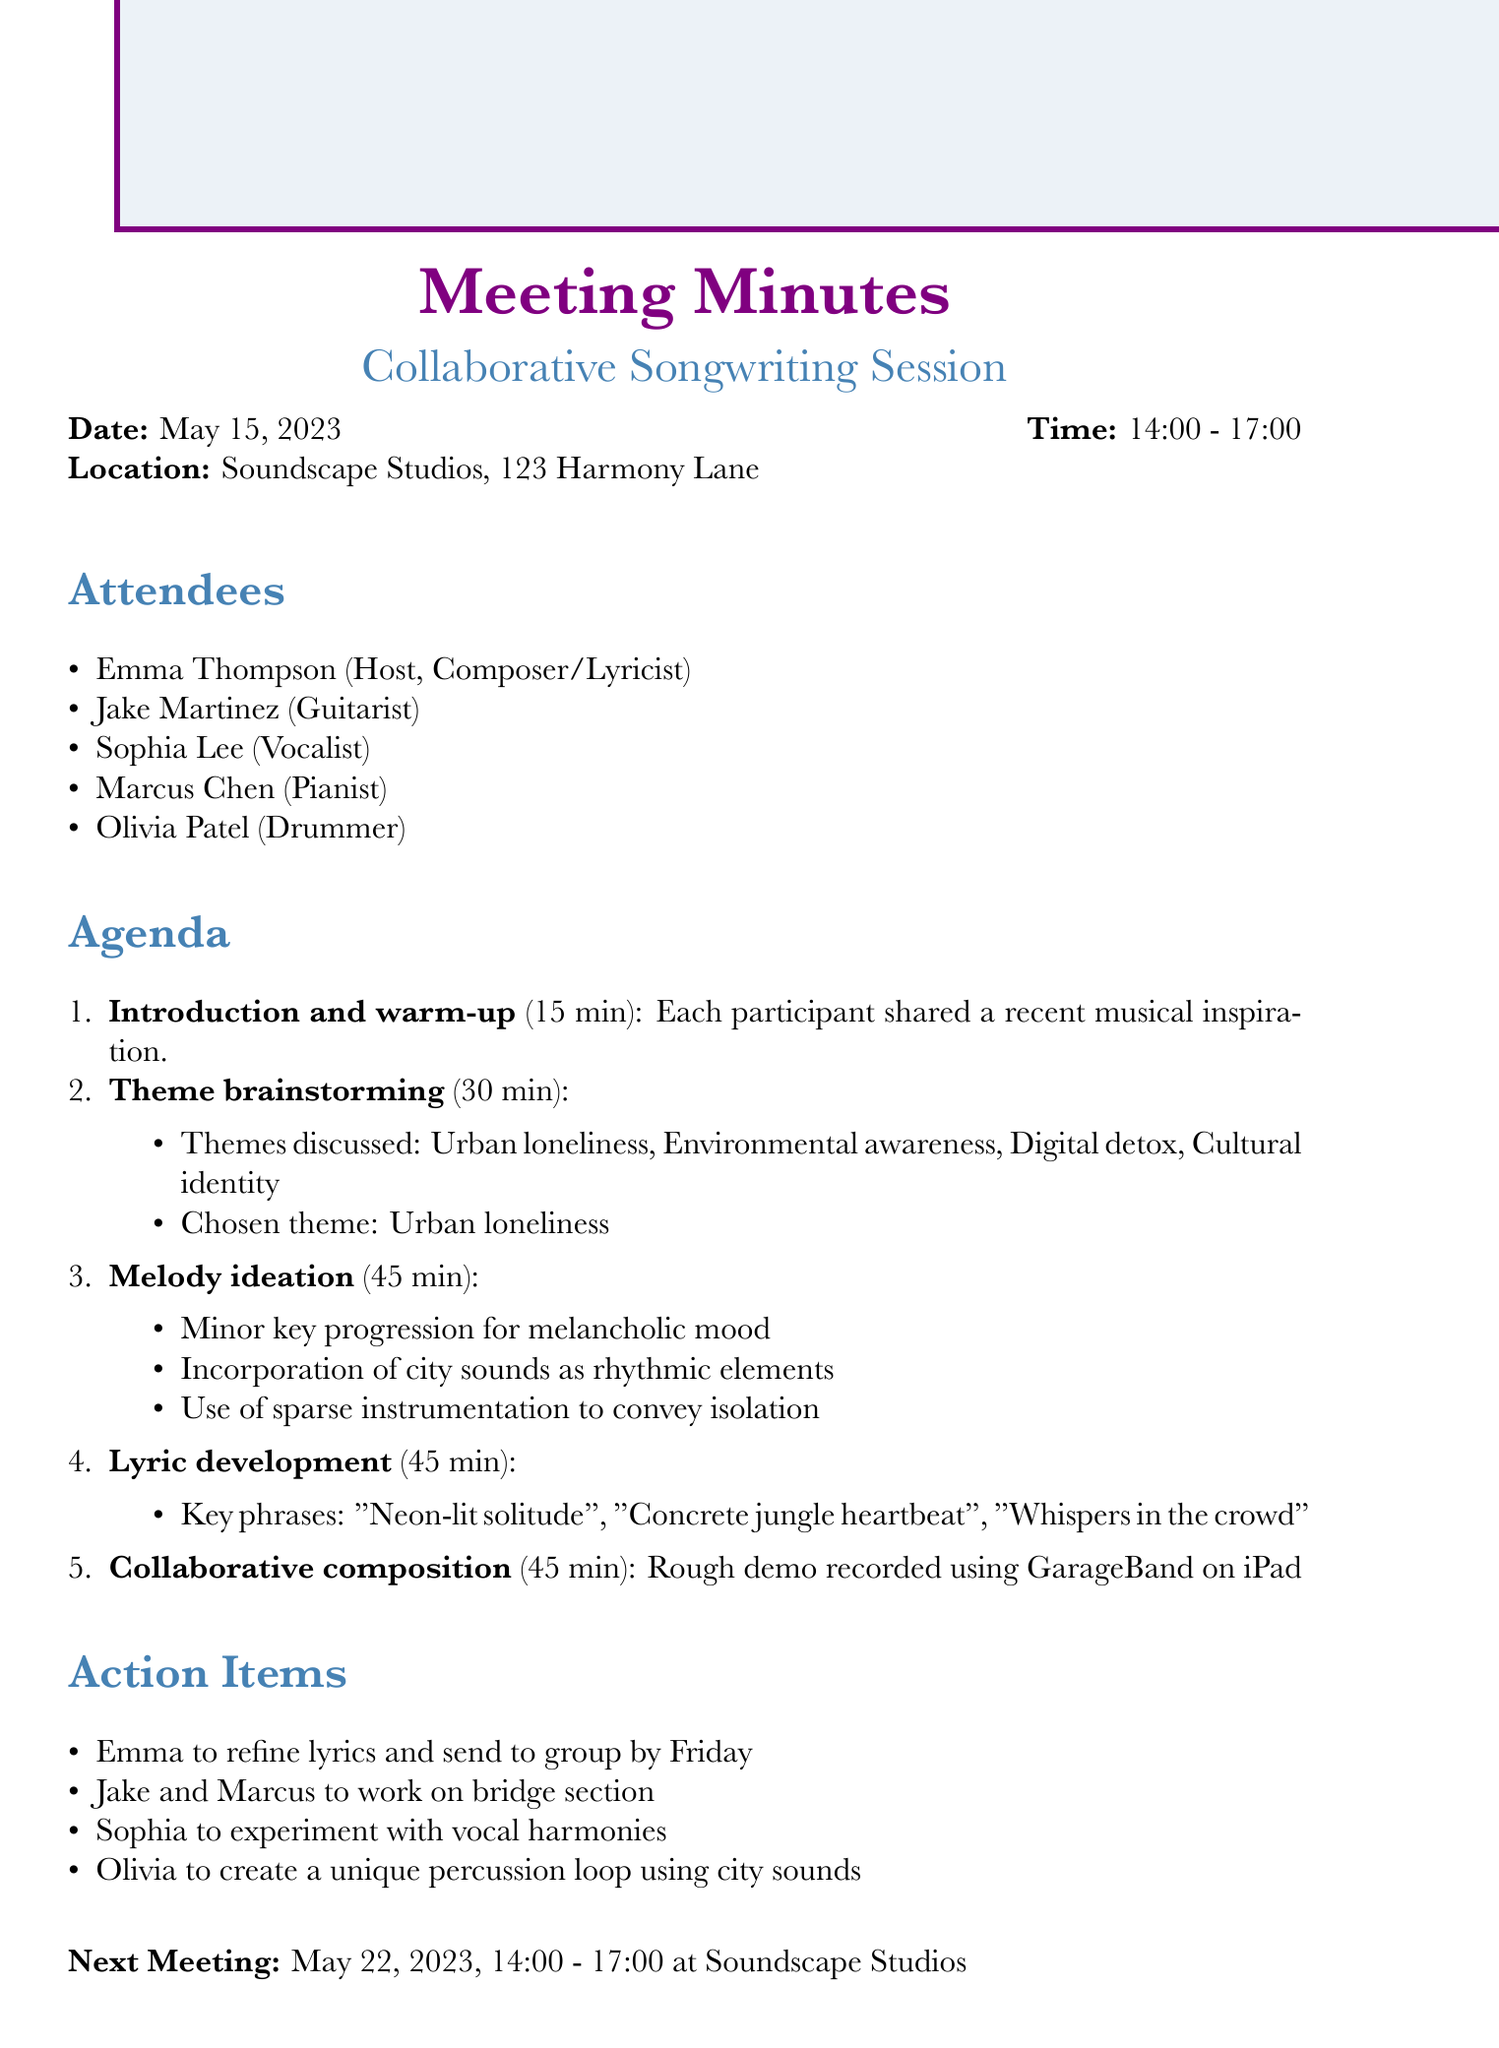what is the date of the meeting? The date of the meeting is stated in the document and is May 15, 2023.
Answer: May 15, 2023 who hosted the meeting? The document specifies Emma Thompson as the host and her role.
Answer: Emma Thompson what is the chosen theme for the songwriting session? The chosen theme is mentioned directly in the theme brainstorming section as Urban loneliness.
Answer: Urban loneliness how long was the melody ideation session? The duration of the melody ideation session is provided in the agenda items.
Answer: 45 minutes what type of sounds were suggested to be incorporated in the melody? The document details ideas discussed during melody ideation; one of them includes city sounds.
Answer: city sounds who will refine the lyrics and send them to the group? The action items list explicitly states who is responsible for refining the lyrics.
Answer: Emma when is the next meeting scheduled? The date and time for the next meeting are clearly indicated at the end of the document.
Answer: May 22, 2023, 14:00 - 17:00 what is the location of the meeting? The location is mentioned in the document, providing a specific venue.
Answer: Soundscape Studios, 123 Harmony Lane 